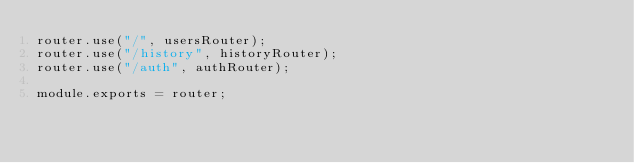<code> <loc_0><loc_0><loc_500><loc_500><_JavaScript_>router.use("/", usersRouter);
router.use("/history", historyRouter);
router.use("/auth", authRouter);

module.exports = router;</code> 